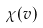Convert formula to latex. <formula><loc_0><loc_0><loc_500><loc_500>\chi ( v )</formula> 